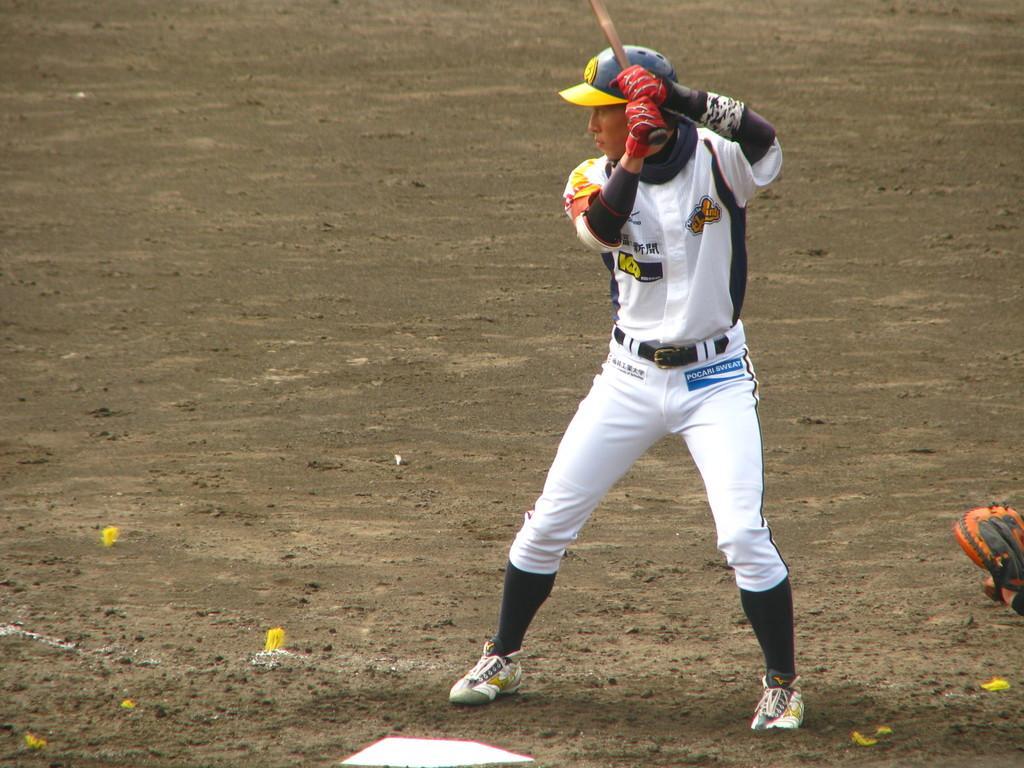Could you give a brief overview of what you see in this image? In this image I can see a person standing facing towards the left, wearing a cap, shoes and holding a stick in his hands. I can see the ground and some objects on the ground. 